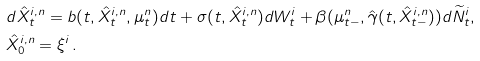<formula> <loc_0><loc_0><loc_500><loc_500>& d \hat { X } ^ { i , n } _ { t } = b ( t , \hat { X } ^ { i , n } _ { t } , \mu ^ { n } _ { t } ) d t + \sigma ( t , \hat { X } ^ { i , n } _ { t } ) d W ^ { i } _ { t } + \beta ( \mu ^ { n } _ { t - } , \hat { \gamma } ( t , \hat { X } _ { t - } ^ { i , n } ) ) d \widetilde { N } ^ { i } _ { t } , \\ & \hat { X } ^ { i , n } _ { 0 } = \xi ^ { i } \, .</formula> 